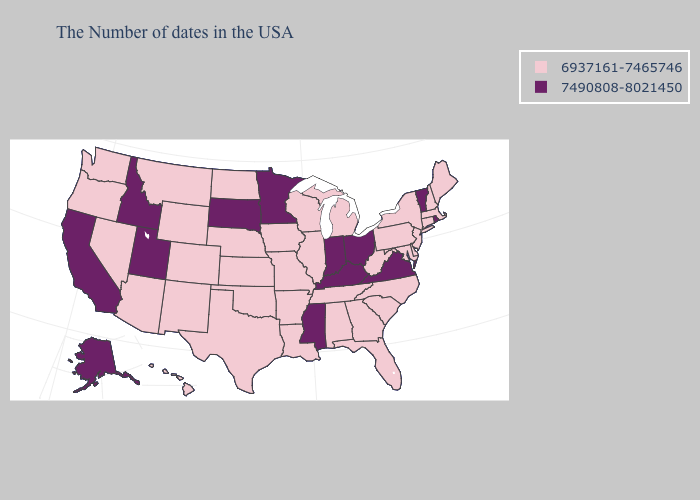Among the states that border Ohio , does Indiana have the highest value?
Give a very brief answer. Yes. What is the value of Nebraska?
Quick response, please. 6937161-7465746. Does Wisconsin have the lowest value in the MidWest?
Give a very brief answer. Yes. What is the lowest value in states that border Ohio?
Write a very short answer. 6937161-7465746. Does the map have missing data?
Give a very brief answer. No. What is the value of Montana?
Write a very short answer. 6937161-7465746. What is the lowest value in states that border North Carolina?
Concise answer only. 6937161-7465746. Name the states that have a value in the range 7490808-8021450?
Give a very brief answer. Rhode Island, Vermont, Virginia, Ohio, Kentucky, Indiana, Mississippi, Minnesota, South Dakota, Utah, Idaho, California, Alaska. What is the highest value in states that border Connecticut?
Give a very brief answer. 7490808-8021450. What is the lowest value in the MidWest?
Give a very brief answer. 6937161-7465746. Which states have the highest value in the USA?
Give a very brief answer. Rhode Island, Vermont, Virginia, Ohio, Kentucky, Indiana, Mississippi, Minnesota, South Dakota, Utah, Idaho, California, Alaska. Name the states that have a value in the range 6937161-7465746?
Answer briefly. Maine, Massachusetts, New Hampshire, Connecticut, New York, New Jersey, Delaware, Maryland, Pennsylvania, North Carolina, South Carolina, West Virginia, Florida, Georgia, Michigan, Alabama, Tennessee, Wisconsin, Illinois, Louisiana, Missouri, Arkansas, Iowa, Kansas, Nebraska, Oklahoma, Texas, North Dakota, Wyoming, Colorado, New Mexico, Montana, Arizona, Nevada, Washington, Oregon, Hawaii. What is the value of Hawaii?
Answer briefly. 6937161-7465746. What is the value of Arkansas?
Quick response, please. 6937161-7465746. 